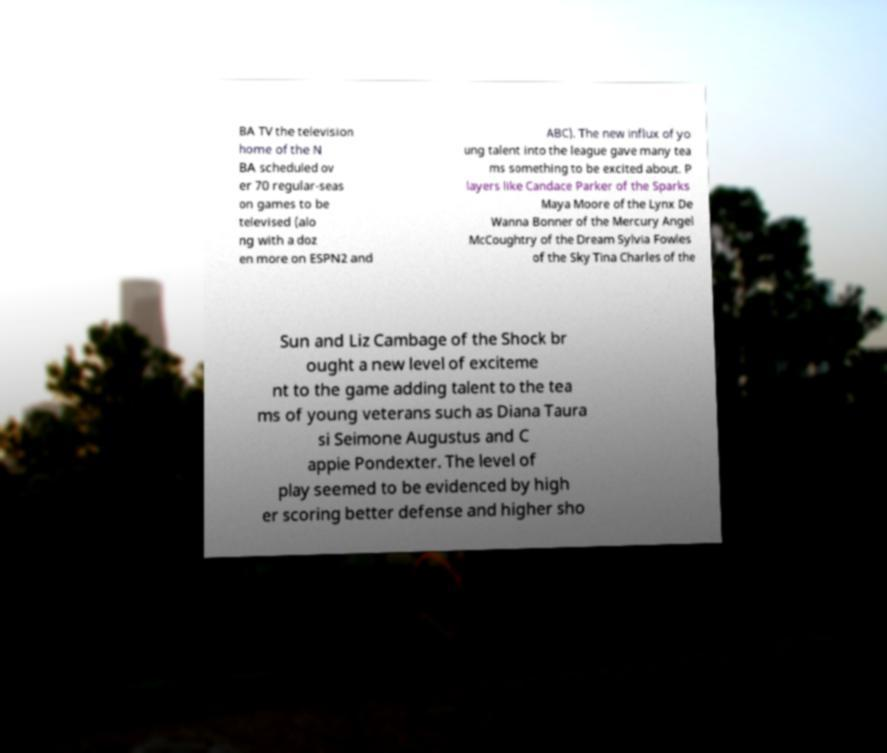For documentation purposes, I need the text within this image transcribed. Could you provide that? BA TV the television home of the N BA scheduled ov er 70 regular-seas on games to be televised (alo ng with a doz en more on ESPN2 and ABC). The new influx of yo ung talent into the league gave many tea ms something to be excited about. P layers like Candace Parker of the Sparks Maya Moore of the Lynx De Wanna Bonner of the Mercury Angel McCoughtry of the Dream Sylvia Fowles of the Sky Tina Charles of the Sun and Liz Cambage of the Shock br ought a new level of exciteme nt to the game adding talent to the tea ms of young veterans such as Diana Taura si Seimone Augustus and C appie Pondexter. The level of play seemed to be evidenced by high er scoring better defense and higher sho 